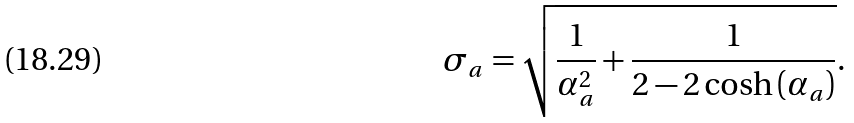<formula> <loc_0><loc_0><loc_500><loc_500>\sigma _ { a } = \sqrt { \frac { 1 } { \alpha _ { a } ^ { 2 } } + \frac { 1 } { 2 - 2 \cosh { \left ( \alpha _ { a } \right ) } } } .</formula> 